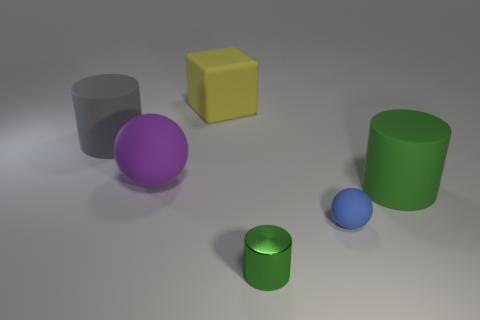Subtract all purple cubes. How many green cylinders are left? 2 Add 4 tiny purple things. How many objects exist? 10 Subtract all spheres. How many objects are left? 4 Add 2 small matte objects. How many small matte objects are left? 3 Add 5 cubes. How many cubes exist? 6 Subtract 0 blue cylinders. How many objects are left? 6 Subtract all small red matte spheres. Subtract all big green cylinders. How many objects are left? 5 